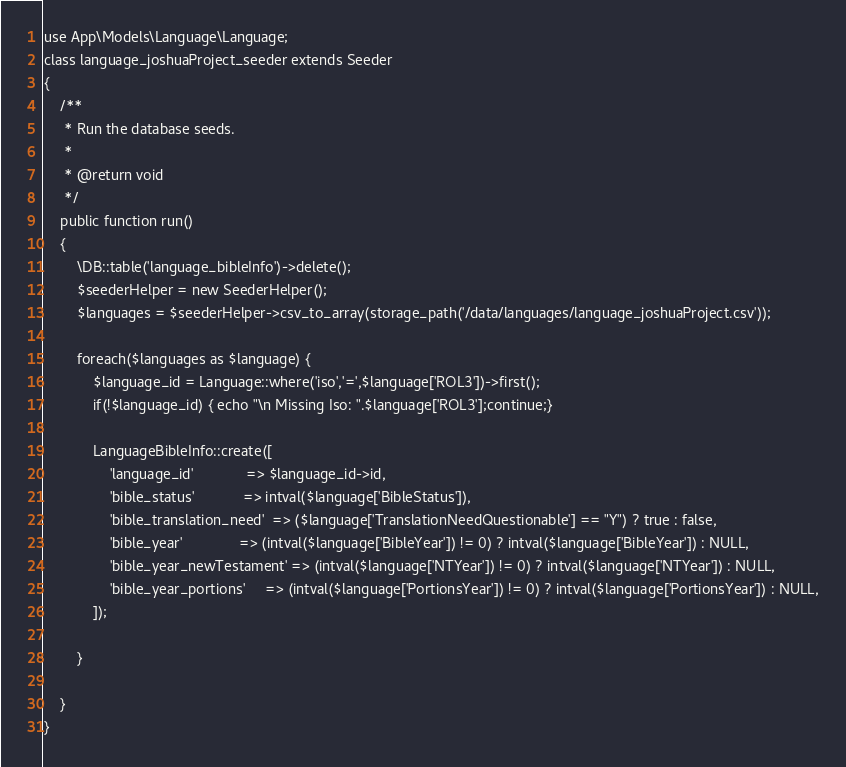<code> <loc_0><loc_0><loc_500><loc_500><_PHP_>use App\Models\Language\Language;
class language_joshuaProject_seeder extends Seeder
{
    /**
     * Run the database seeds.
     *
     * @return void
     */
    public function run()
    {
		\DB::table('language_bibleInfo')->delete();
	    $seederHelper = new SeederHelper();
	    $languages = $seederHelper->csv_to_array(storage_path('/data/languages/language_joshuaProject.csv'));

	    foreach($languages as $language) {
			$language_id = Language::where('iso','=',$language['ROL3'])->first();
			if(!$language_id) { echo "\n Missing Iso: ".$language['ROL3'];continue;}

		    LanguageBibleInfo::create([
		    	'language_id'             => $language_id->id,
			    'bible_status'            => intval($language['BibleStatus']),
			    'bible_translation_need'  => ($language['TranslationNeedQuestionable'] == "Y") ? true : false,
			    'bible_year'              => (intval($language['BibleYear']) != 0) ? intval($language['BibleYear']) : NULL,
			    'bible_year_newTestament' => (intval($language['NTYear']) != 0) ? intval($language['NTYear']) : NULL,
			    'bible_year_portions'     => (intval($language['PortionsYear']) != 0) ? intval($language['PortionsYear']) : NULL,
		    ]);

	    }

    }
}
</code> 